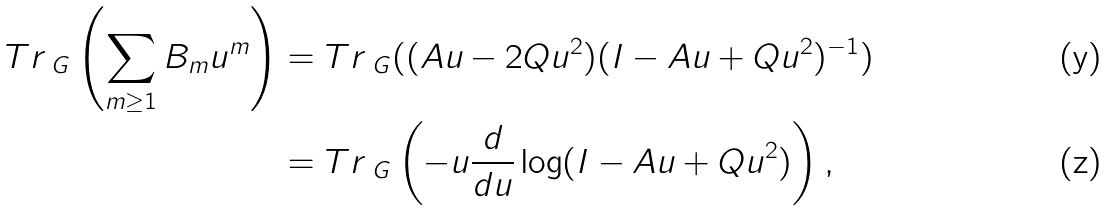Convert formula to latex. <formula><loc_0><loc_0><loc_500><loc_500>T r _ { \ G } \left ( \sum _ { m \geq 1 } B _ { m } u ^ { m } \right ) & = T r _ { \ G } ( ( A u - 2 Q u ^ { 2 } ) ( I - A u + Q u ^ { 2 } ) ^ { - 1 } ) \\ & = T r _ { \ G } \left ( - u \frac { d } { d u } \log ( I - A u + Q u ^ { 2 } ) \right ) ,</formula> 